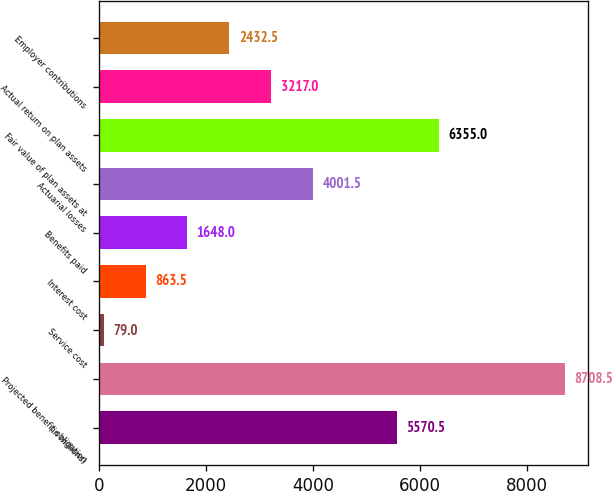<chart> <loc_0><loc_0><loc_500><loc_500><bar_chart><fcel>(in millions)<fcel>Projected benefit obligation<fcel>Service cost<fcel>Interest cost<fcel>Benefits paid<fcel>Actuarial losses<fcel>Fair value of plan assets at<fcel>Actual return on plan assets<fcel>Employer contributions<nl><fcel>5570.5<fcel>8708.5<fcel>79<fcel>863.5<fcel>1648<fcel>4001.5<fcel>6355<fcel>3217<fcel>2432.5<nl></chart> 